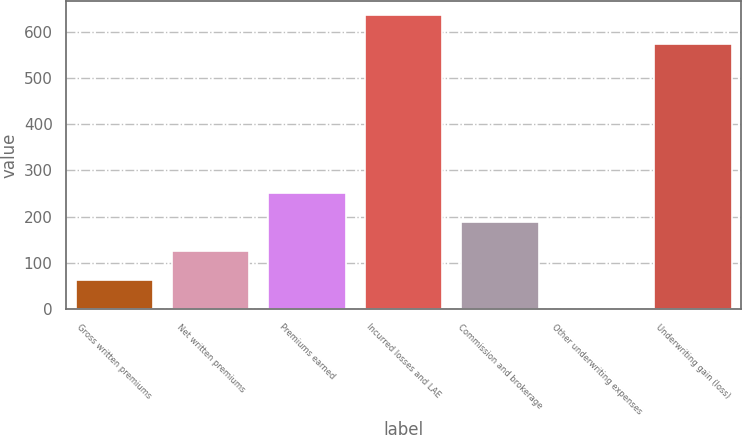Convert chart to OTSL. <chart><loc_0><loc_0><loc_500><loc_500><bar_chart><fcel>Gross written premiums<fcel>Net written premiums<fcel>Premiums earned<fcel>Incurred losses and LAE<fcel>Commission and brokerage<fcel>Other underwriting expenses<fcel>Underwriting gain (loss)<nl><fcel>63.74<fcel>126.48<fcel>251.96<fcel>635.04<fcel>189.22<fcel>1<fcel>572.3<nl></chart> 